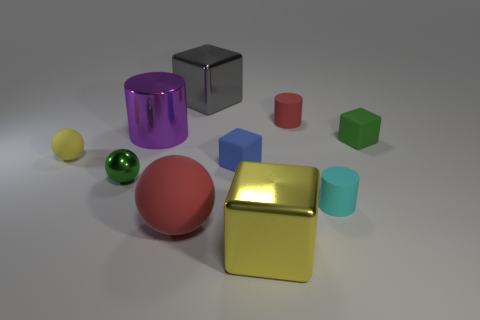Subtract all big cylinders. How many cylinders are left? 2 Subtract all yellow balls. How many balls are left? 2 Subtract 1 red cylinders. How many objects are left? 9 Subtract all blocks. How many objects are left? 6 Subtract 2 spheres. How many spheres are left? 1 Subtract all gray cylinders. Subtract all cyan blocks. How many cylinders are left? 3 Subtract all red cylinders. How many yellow balls are left? 1 Subtract all purple shiny cylinders. Subtract all green spheres. How many objects are left? 8 Add 2 small yellow balls. How many small yellow balls are left? 3 Add 2 yellow spheres. How many yellow spheres exist? 3 